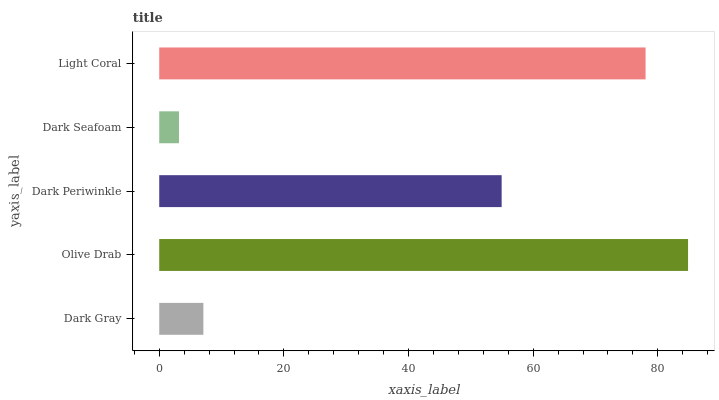Is Dark Seafoam the minimum?
Answer yes or no. Yes. Is Olive Drab the maximum?
Answer yes or no. Yes. Is Dark Periwinkle the minimum?
Answer yes or no. No. Is Dark Periwinkle the maximum?
Answer yes or no. No. Is Olive Drab greater than Dark Periwinkle?
Answer yes or no. Yes. Is Dark Periwinkle less than Olive Drab?
Answer yes or no. Yes. Is Dark Periwinkle greater than Olive Drab?
Answer yes or no. No. Is Olive Drab less than Dark Periwinkle?
Answer yes or no. No. Is Dark Periwinkle the high median?
Answer yes or no. Yes. Is Dark Periwinkle the low median?
Answer yes or no. Yes. Is Dark Gray the high median?
Answer yes or no. No. Is Dark Seafoam the low median?
Answer yes or no. No. 